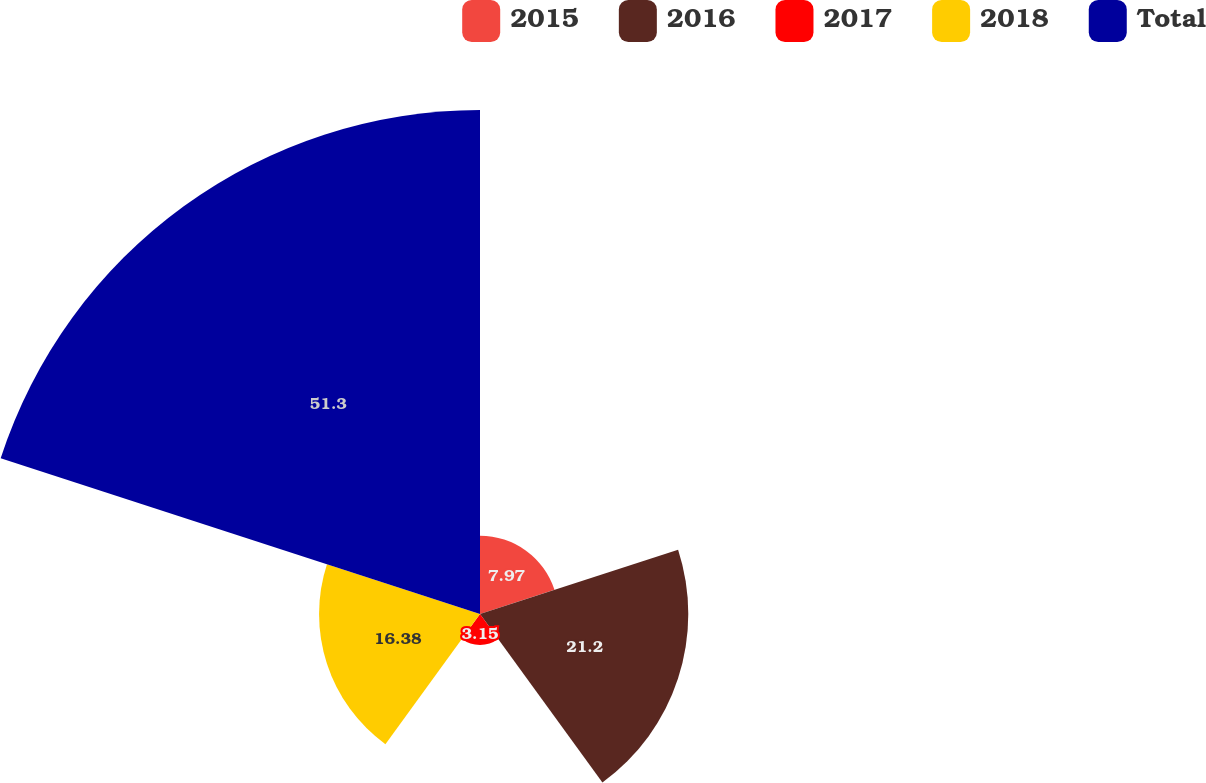<chart> <loc_0><loc_0><loc_500><loc_500><pie_chart><fcel>2015<fcel>2016<fcel>2017<fcel>2018<fcel>Total<nl><fcel>7.97%<fcel>21.2%<fcel>3.15%<fcel>16.38%<fcel>51.3%<nl></chart> 